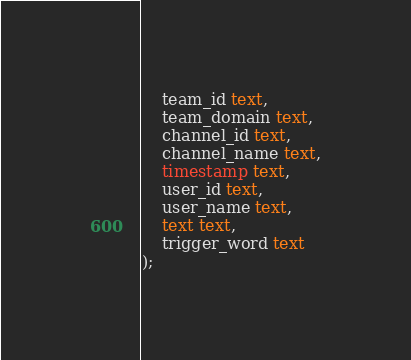<code> <loc_0><loc_0><loc_500><loc_500><_SQL_>    team_id text,
    team_domain text,
    channel_id text,
    channel_name text,
    timestamp text,
    user_id text,
    user_name text,
    text text,
    trigger_word text
);
</code> 